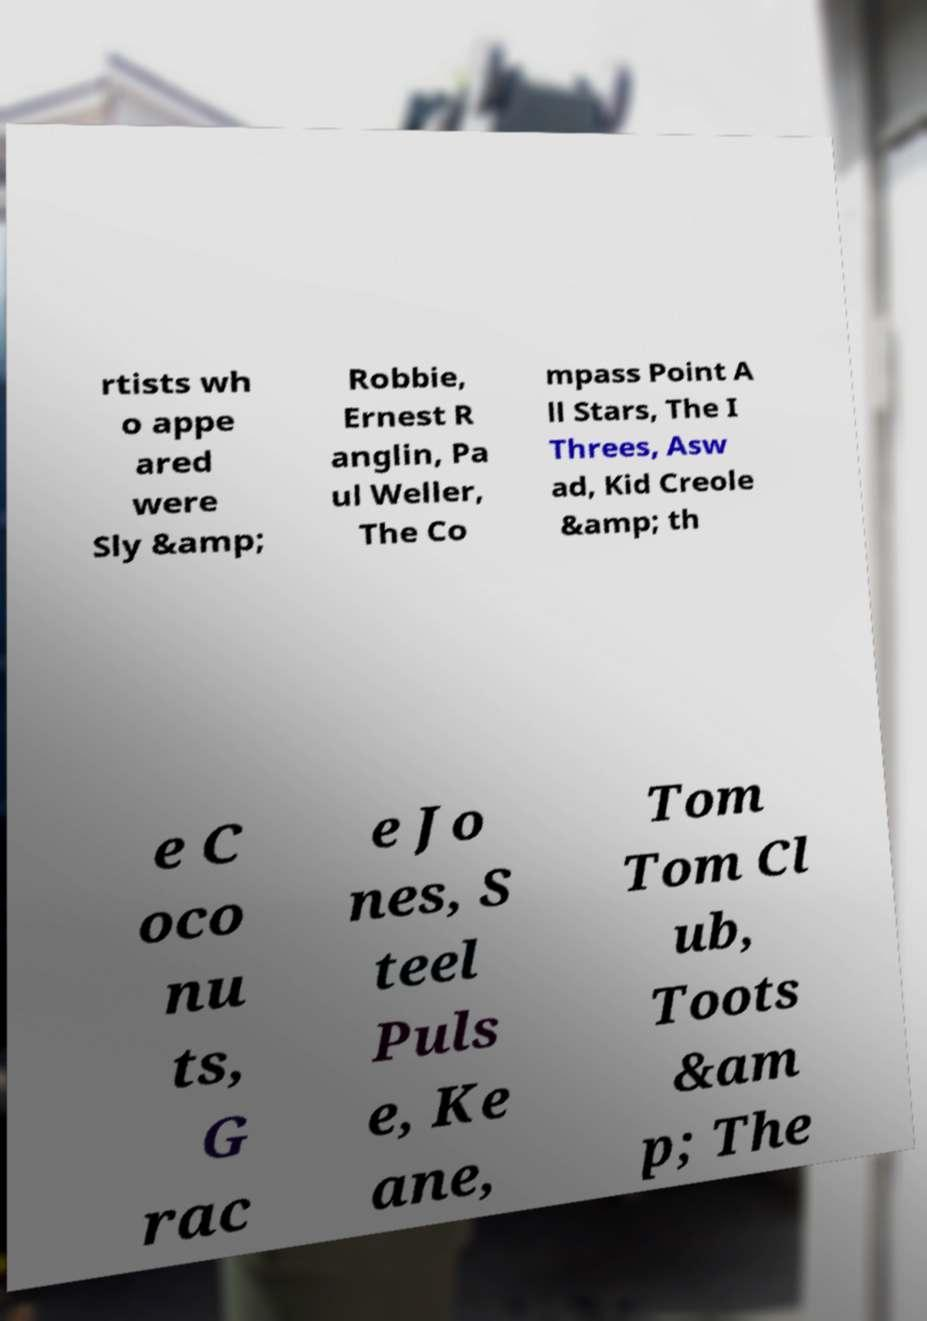Please identify and transcribe the text found in this image. rtists wh o appe ared were Sly &amp; Robbie, Ernest R anglin, Pa ul Weller, The Co mpass Point A ll Stars, The I Threes, Asw ad, Kid Creole &amp; th e C oco nu ts, G rac e Jo nes, S teel Puls e, Ke ane, Tom Tom Cl ub, Toots &am p; The 